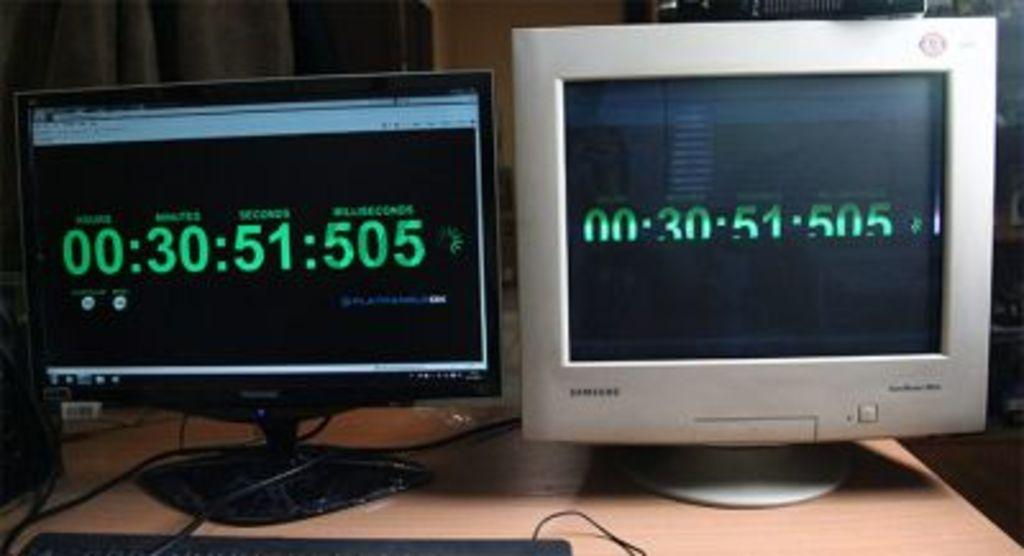<image>
Present a compact description of the photo's key features. Two monitors side by side with the timecode 00:30:51:505 